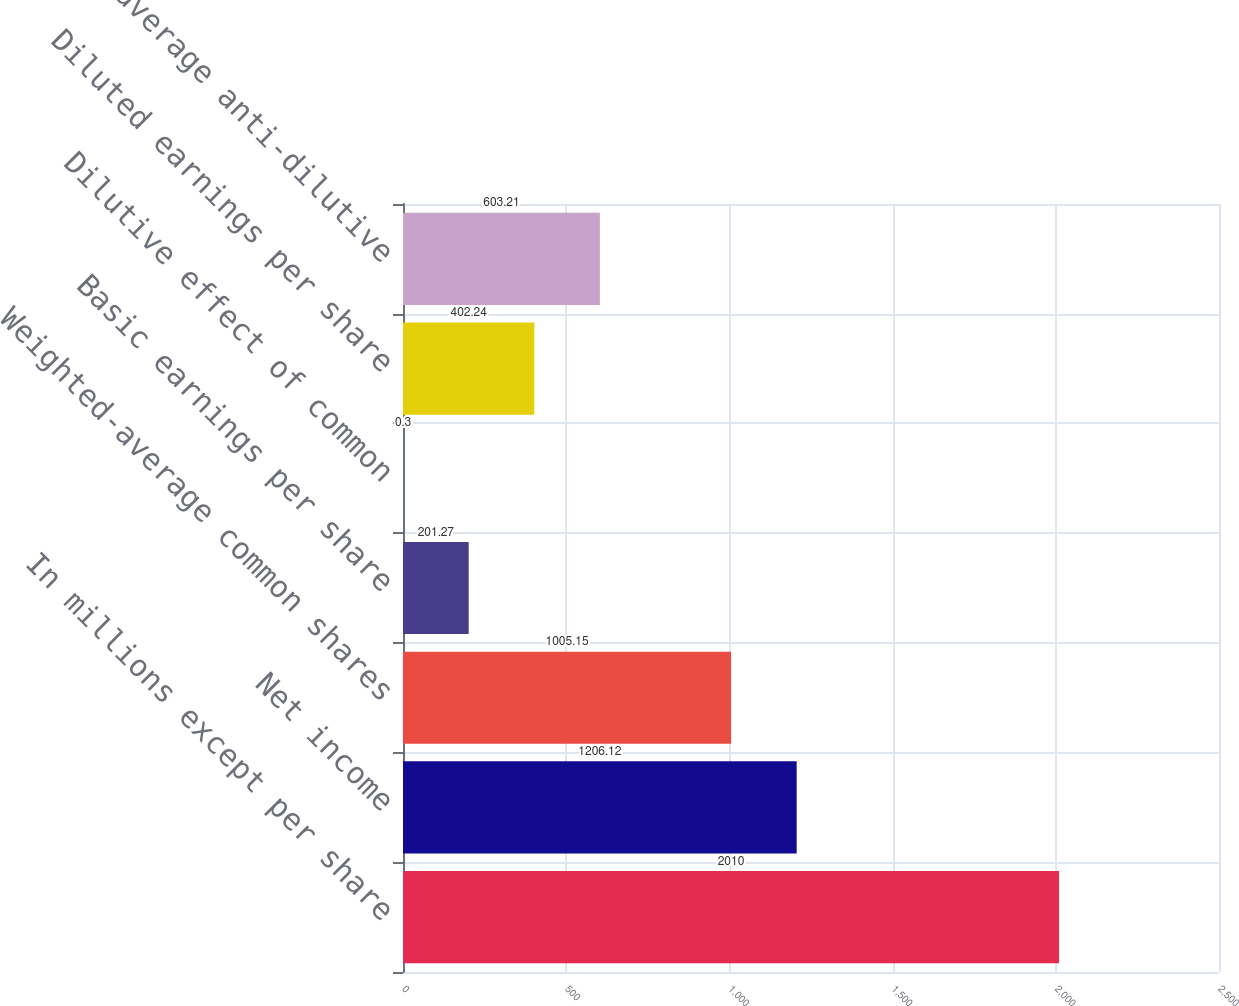Convert chart to OTSL. <chart><loc_0><loc_0><loc_500><loc_500><bar_chart><fcel>In millions except per share<fcel>Net income<fcel>Weighted-average common shares<fcel>Basic earnings per share<fcel>Dilutive effect of common<fcel>Diluted earnings per share<fcel>Weighted-average anti-dilutive<nl><fcel>2010<fcel>1206.12<fcel>1005.15<fcel>201.27<fcel>0.3<fcel>402.24<fcel>603.21<nl></chart> 